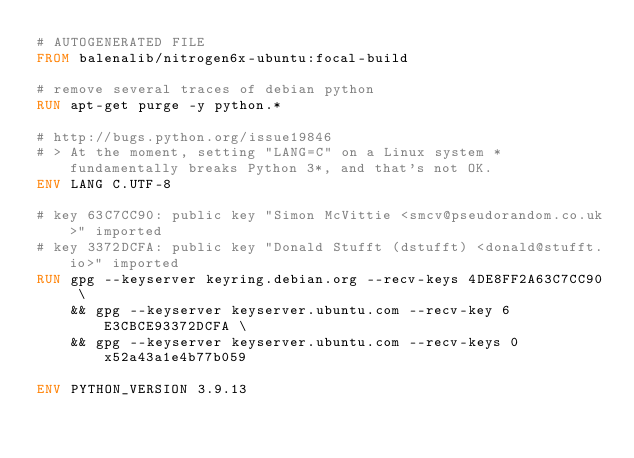Convert code to text. <code><loc_0><loc_0><loc_500><loc_500><_Dockerfile_># AUTOGENERATED FILE
FROM balenalib/nitrogen6x-ubuntu:focal-build

# remove several traces of debian python
RUN apt-get purge -y python.*

# http://bugs.python.org/issue19846
# > At the moment, setting "LANG=C" on a Linux system *fundamentally breaks Python 3*, and that's not OK.
ENV LANG C.UTF-8

# key 63C7CC90: public key "Simon McVittie <smcv@pseudorandom.co.uk>" imported
# key 3372DCFA: public key "Donald Stufft (dstufft) <donald@stufft.io>" imported
RUN gpg --keyserver keyring.debian.org --recv-keys 4DE8FF2A63C7CC90 \
	&& gpg --keyserver keyserver.ubuntu.com --recv-key 6E3CBCE93372DCFA \
	&& gpg --keyserver keyserver.ubuntu.com --recv-keys 0x52a43a1e4b77b059

ENV PYTHON_VERSION 3.9.13
</code> 